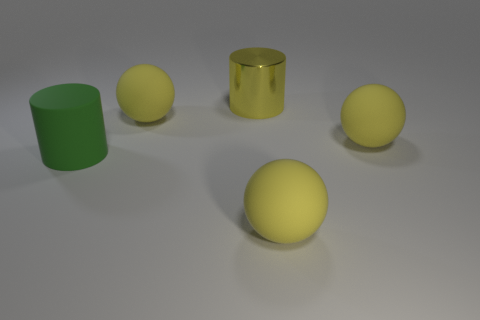What is the shape of the big rubber thing to the left of the big yellow matte sphere on the left side of the big yellow cylinder?
Keep it short and to the point. Cylinder. How big is the cylinder behind the large cylinder in front of the yellow cylinder on the right side of the large green rubber object?
Your response must be concise. Large. Is the size of the green cylinder the same as the yellow shiny thing?
Your response must be concise. Yes. What number of objects are either spheres or big red cylinders?
Your answer should be compact. 3. There is a cylinder left of the matte ball that is to the left of the large yellow cylinder; how big is it?
Offer a very short reply. Large. What size is the green rubber thing?
Give a very brief answer. Large. What is the shape of the object that is both left of the large yellow metallic cylinder and on the right side of the green cylinder?
Ensure brevity in your answer.  Sphere. There is a large rubber object that is the same shape as the yellow metal object; what is its color?
Provide a short and direct response. Green. What number of things are either yellow rubber balls that are behind the green cylinder or big yellow objects in front of the large green matte object?
Your answer should be compact. 3. The green object has what shape?
Provide a short and direct response. Cylinder. 